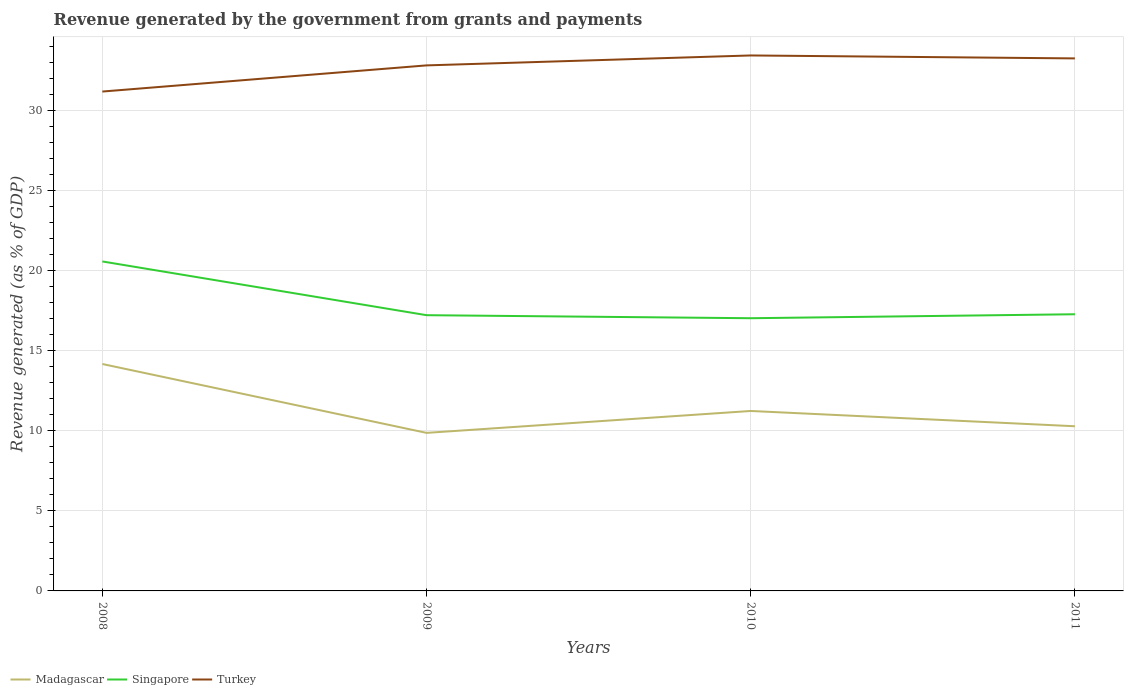Is the number of lines equal to the number of legend labels?
Make the answer very short. Yes. Across all years, what is the maximum revenue generated by the government in Singapore?
Provide a succinct answer. 17.02. In which year was the revenue generated by the government in Turkey maximum?
Keep it short and to the point. 2008. What is the total revenue generated by the government in Singapore in the graph?
Your answer should be very brief. 3.35. What is the difference between the highest and the second highest revenue generated by the government in Singapore?
Your answer should be compact. 3.54. Is the revenue generated by the government in Madagascar strictly greater than the revenue generated by the government in Turkey over the years?
Keep it short and to the point. Yes. What is the difference between two consecutive major ticks on the Y-axis?
Ensure brevity in your answer.  5. Does the graph contain grids?
Give a very brief answer. Yes. Where does the legend appear in the graph?
Your answer should be very brief. Bottom left. How many legend labels are there?
Ensure brevity in your answer.  3. How are the legend labels stacked?
Give a very brief answer. Horizontal. What is the title of the graph?
Your answer should be compact. Revenue generated by the government from grants and payments. Does "China" appear as one of the legend labels in the graph?
Your answer should be very brief. No. What is the label or title of the X-axis?
Give a very brief answer. Years. What is the label or title of the Y-axis?
Ensure brevity in your answer.  Revenue generated (as % of GDP). What is the Revenue generated (as % of GDP) of Madagascar in 2008?
Keep it short and to the point. 14.16. What is the Revenue generated (as % of GDP) of Singapore in 2008?
Provide a short and direct response. 20.56. What is the Revenue generated (as % of GDP) of Turkey in 2008?
Offer a very short reply. 31.17. What is the Revenue generated (as % of GDP) in Madagascar in 2009?
Keep it short and to the point. 9.86. What is the Revenue generated (as % of GDP) in Singapore in 2009?
Offer a terse response. 17.21. What is the Revenue generated (as % of GDP) in Turkey in 2009?
Offer a terse response. 32.8. What is the Revenue generated (as % of GDP) of Madagascar in 2010?
Keep it short and to the point. 11.23. What is the Revenue generated (as % of GDP) of Singapore in 2010?
Give a very brief answer. 17.02. What is the Revenue generated (as % of GDP) of Turkey in 2010?
Offer a terse response. 33.42. What is the Revenue generated (as % of GDP) in Madagascar in 2011?
Provide a short and direct response. 10.28. What is the Revenue generated (as % of GDP) in Singapore in 2011?
Ensure brevity in your answer.  17.27. What is the Revenue generated (as % of GDP) in Turkey in 2011?
Provide a succinct answer. 33.23. Across all years, what is the maximum Revenue generated (as % of GDP) in Madagascar?
Offer a terse response. 14.16. Across all years, what is the maximum Revenue generated (as % of GDP) of Singapore?
Your answer should be very brief. 20.56. Across all years, what is the maximum Revenue generated (as % of GDP) of Turkey?
Your answer should be very brief. 33.42. Across all years, what is the minimum Revenue generated (as % of GDP) of Madagascar?
Your answer should be very brief. 9.86. Across all years, what is the minimum Revenue generated (as % of GDP) in Singapore?
Your answer should be very brief. 17.02. Across all years, what is the minimum Revenue generated (as % of GDP) in Turkey?
Provide a short and direct response. 31.17. What is the total Revenue generated (as % of GDP) of Madagascar in the graph?
Make the answer very short. 45.53. What is the total Revenue generated (as % of GDP) in Singapore in the graph?
Keep it short and to the point. 72.06. What is the total Revenue generated (as % of GDP) in Turkey in the graph?
Provide a short and direct response. 130.62. What is the difference between the Revenue generated (as % of GDP) of Madagascar in 2008 and that in 2009?
Your response must be concise. 4.3. What is the difference between the Revenue generated (as % of GDP) of Singapore in 2008 and that in 2009?
Give a very brief answer. 3.35. What is the difference between the Revenue generated (as % of GDP) of Turkey in 2008 and that in 2009?
Offer a very short reply. -1.63. What is the difference between the Revenue generated (as % of GDP) in Madagascar in 2008 and that in 2010?
Make the answer very short. 2.93. What is the difference between the Revenue generated (as % of GDP) of Singapore in 2008 and that in 2010?
Provide a succinct answer. 3.54. What is the difference between the Revenue generated (as % of GDP) of Turkey in 2008 and that in 2010?
Give a very brief answer. -2.25. What is the difference between the Revenue generated (as % of GDP) of Madagascar in 2008 and that in 2011?
Ensure brevity in your answer.  3.88. What is the difference between the Revenue generated (as % of GDP) of Singapore in 2008 and that in 2011?
Provide a short and direct response. 3.29. What is the difference between the Revenue generated (as % of GDP) of Turkey in 2008 and that in 2011?
Offer a terse response. -2.07. What is the difference between the Revenue generated (as % of GDP) in Madagascar in 2009 and that in 2010?
Your answer should be very brief. -1.37. What is the difference between the Revenue generated (as % of GDP) in Singapore in 2009 and that in 2010?
Your response must be concise. 0.19. What is the difference between the Revenue generated (as % of GDP) in Turkey in 2009 and that in 2010?
Your response must be concise. -0.62. What is the difference between the Revenue generated (as % of GDP) in Madagascar in 2009 and that in 2011?
Provide a succinct answer. -0.41. What is the difference between the Revenue generated (as % of GDP) of Singapore in 2009 and that in 2011?
Provide a succinct answer. -0.06. What is the difference between the Revenue generated (as % of GDP) in Turkey in 2009 and that in 2011?
Your response must be concise. -0.44. What is the difference between the Revenue generated (as % of GDP) of Madagascar in 2010 and that in 2011?
Provide a succinct answer. 0.95. What is the difference between the Revenue generated (as % of GDP) in Singapore in 2010 and that in 2011?
Your answer should be compact. -0.25. What is the difference between the Revenue generated (as % of GDP) of Turkey in 2010 and that in 2011?
Keep it short and to the point. 0.18. What is the difference between the Revenue generated (as % of GDP) in Madagascar in 2008 and the Revenue generated (as % of GDP) in Singapore in 2009?
Ensure brevity in your answer.  -3.05. What is the difference between the Revenue generated (as % of GDP) in Madagascar in 2008 and the Revenue generated (as % of GDP) in Turkey in 2009?
Keep it short and to the point. -18.64. What is the difference between the Revenue generated (as % of GDP) in Singapore in 2008 and the Revenue generated (as % of GDP) in Turkey in 2009?
Provide a short and direct response. -12.24. What is the difference between the Revenue generated (as % of GDP) of Madagascar in 2008 and the Revenue generated (as % of GDP) of Singapore in 2010?
Offer a very short reply. -2.86. What is the difference between the Revenue generated (as % of GDP) of Madagascar in 2008 and the Revenue generated (as % of GDP) of Turkey in 2010?
Offer a very short reply. -19.26. What is the difference between the Revenue generated (as % of GDP) of Singapore in 2008 and the Revenue generated (as % of GDP) of Turkey in 2010?
Ensure brevity in your answer.  -12.86. What is the difference between the Revenue generated (as % of GDP) of Madagascar in 2008 and the Revenue generated (as % of GDP) of Singapore in 2011?
Your answer should be compact. -3.11. What is the difference between the Revenue generated (as % of GDP) of Madagascar in 2008 and the Revenue generated (as % of GDP) of Turkey in 2011?
Provide a short and direct response. -19.07. What is the difference between the Revenue generated (as % of GDP) in Singapore in 2008 and the Revenue generated (as % of GDP) in Turkey in 2011?
Provide a succinct answer. -12.67. What is the difference between the Revenue generated (as % of GDP) in Madagascar in 2009 and the Revenue generated (as % of GDP) in Singapore in 2010?
Provide a short and direct response. -7.16. What is the difference between the Revenue generated (as % of GDP) in Madagascar in 2009 and the Revenue generated (as % of GDP) in Turkey in 2010?
Make the answer very short. -23.56. What is the difference between the Revenue generated (as % of GDP) in Singapore in 2009 and the Revenue generated (as % of GDP) in Turkey in 2010?
Give a very brief answer. -16.21. What is the difference between the Revenue generated (as % of GDP) of Madagascar in 2009 and the Revenue generated (as % of GDP) of Singapore in 2011?
Offer a very short reply. -7.4. What is the difference between the Revenue generated (as % of GDP) in Madagascar in 2009 and the Revenue generated (as % of GDP) in Turkey in 2011?
Offer a very short reply. -23.37. What is the difference between the Revenue generated (as % of GDP) in Singapore in 2009 and the Revenue generated (as % of GDP) in Turkey in 2011?
Make the answer very short. -16.03. What is the difference between the Revenue generated (as % of GDP) of Madagascar in 2010 and the Revenue generated (as % of GDP) of Singapore in 2011?
Provide a short and direct response. -6.04. What is the difference between the Revenue generated (as % of GDP) in Madagascar in 2010 and the Revenue generated (as % of GDP) in Turkey in 2011?
Your answer should be compact. -22. What is the difference between the Revenue generated (as % of GDP) in Singapore in 2010 and the Revenue generated (as % of GDP) in Turkey in 2011?
Your answer should be very brief. -16.22. What is the average Revenue generated (as % of GDP) of Madagascar per year?
Offer a very short reply. 11.38. What is the average Revenue generated (as % of GDP) of Singapore per year?
Make the answer very short. 18.01. What is the average Revenue generated (as % of GDP) of Turkey per year?
Offer a terse response. 32.65. In the year 2008, what is the difference between the Revenue generated (as % of GDP) of Madagascar and Revenue generated (as % of GDP) of Singapore?
Ensure brevity in your answer.  -6.4. In the year 2008, what is the difference between the Revenue generated (as % of GDP) in Madagascar and Revenue generated (as % of GDP) in Turkey?
Ensure brevity in your answer.  -17. In the year 2008, what is the difference between the Revenue generated (as % of GDP) of Singapore and Revenue generated (as % of GDP) of Turkey?
Offer a terse response. -10.6. In the year 2009, what is the difference between the Revenue generated (as % of GDP) in Madagascar and Revenue generated (as % of GDP) in Singapore?
Your answer should be very brief. -7.34. In the year 2009, what is the difference between the Revenue generated (as % of GDP) in Madagascar and Revenue generated (as % of GDP) in Turkey?
Your answer should be compact. -22.93. In the year 2009, what is the difference between the Revenue generated (as % of GDP) in Singapore and Revenue generated (as % of GDP) in Turkey?
Ensure brevity in your answer.  -15.59. In the year 2010, what is the difference between the Revenue generated (as % of GDP) in Madagascar and Revenue generated (as % of GDP) in Singapore?
Ensure brevity in your answer.  -5.79. In the year 2010, what is the difference between the Revenue generated (as % of GDP) of Madagascar and Revenue generated (as % of GDP) of Turkey?
Make the answer very short. -22.19. In the year 2010, what is the difference between the Revenue generated (as % of GDP) in Singapore and Revenue generated (as % of GDP) in Turkey?
Keep it short and to the point. -16.4. In the year 2011, what is the difference between the Revenue generated (as % of GDP) of Madagascar and Revenue generated (as % of GDP) of Singapore?
Provide a succinct answer. -6.99. In the year 2011, what is the difference between the Revenue generated (as % of GDP) of Madagascar and Revenue generated (as % of GDP) of Turkey?
Offer a terse response. -22.96. In the year 2011, what is the difference between the Revenue generated (as % of GDP) in Singapore and Revenue generated (as % of GDP) in Turkey?
Ensure brevity in your answer.  -15.97. What is the ratio of the Revenue generated (as % of GDP) of Madagascar in 2008 to that in 2009?
Offer a very short reply. 1.44. What is the ratio of the Revenue generated (as % of GDP) of Singapore in 2008 to that in 2009?
Your response must be concise. 1.19. What is the ratio of the Revenue generated (as % of GDP) in Turkey in 2008 to that in 2009?
Keep it short and to the point. 0.95. What is the ratio of the Revenue generated (as % of GDP) in Madagascar in 2008 to that in 2010?
Provide a short and direct response. 1.26. What is the ratio of the Revenue generated (as % of GDP) of Singapore in 2008 to that in 2010?
Provide a short and direct response. 1.21. What is the ratio of the Revenue generated (as % of GDP) in Turkey in 2008 to that in 2010?
Offer a very short reply. 0.93. What is the ratio of the Revenue generated (as % of GDP) in Madagascar in 2008 to that in 2011?
Your response must be concise. 1.38. What is the ratio of the Revenue generated (as % of GDP) of Singapore in 2008 to that in 2011?
Give a very brief answer. 1.19. What is the ratio of the Revenue generated (as % of GDP) of Turkey in 2008 to that in 2011?
Your answer should be compact. 0.94. What is the ratio of the Revenue generated (as % of GDP) in Madagascar in 2009 to that in 2010?
Keep it short and to the point. 0.88. What is the ratio of the Revenue generated (as % of GDP) in Singapore in 2009 to that in 2010?
Give a very brief answer. 1.01. What is the ratio of the Revenue generated (as % of GDP) of Turkey in 2009 to that in 2010?
Your answer should be compact. 0.98. What is the ratio of the Revenue generated (as % of GDP) of Madagascar in 2009 to that in 2011?
Your response must be concise. 0.96. What is the ratio of the Revenue generated (as % of GDP) of Turkey in 2009 to that in 2011?
Ensure brevity in your answer.  0.99. What is the ratio of the Revenue generated (as % of GDP) in Madagascar in 2010 to that in 2011?
Your response must be concise. 1.09. What is the ratio of the Revenue generated (as % of GDP) of Singapore in 2010 to that in 2011?
Provide a short and direct response. 0.99. What is the ratio of the Revenue generated (as % of GDP) in Turkey in 2010 to that in 2011?
Offer a terse response. 1.01. What is the difference between the highest and the second highest Revenue generated (as % of GDP) in Madagascar?
Offer a very short reply. 2.93. What is the difference between the highest and the second highest Revenue generated (as % of GDP) of Singapore?
Your response must be concise. 3.29. What is the difference between the highest and the second highest Revenue generated (as % of GDP) in Turkey?
Your answer should be compact. 0.18. What is the difference between the highest and the lowest Revenue generated (as % of GDP) in Madagascar?
Keep it short and to the point. 4.3. What is the difference between the highest and the lowest Revenue generated (as % of GDP) in Singapore?
Give a very brief answer. 3.54. What is the difference between the highest and the lowest Revenue generated (as % of GDP) in Turkey?
Your answer should be compact. 2.25. 